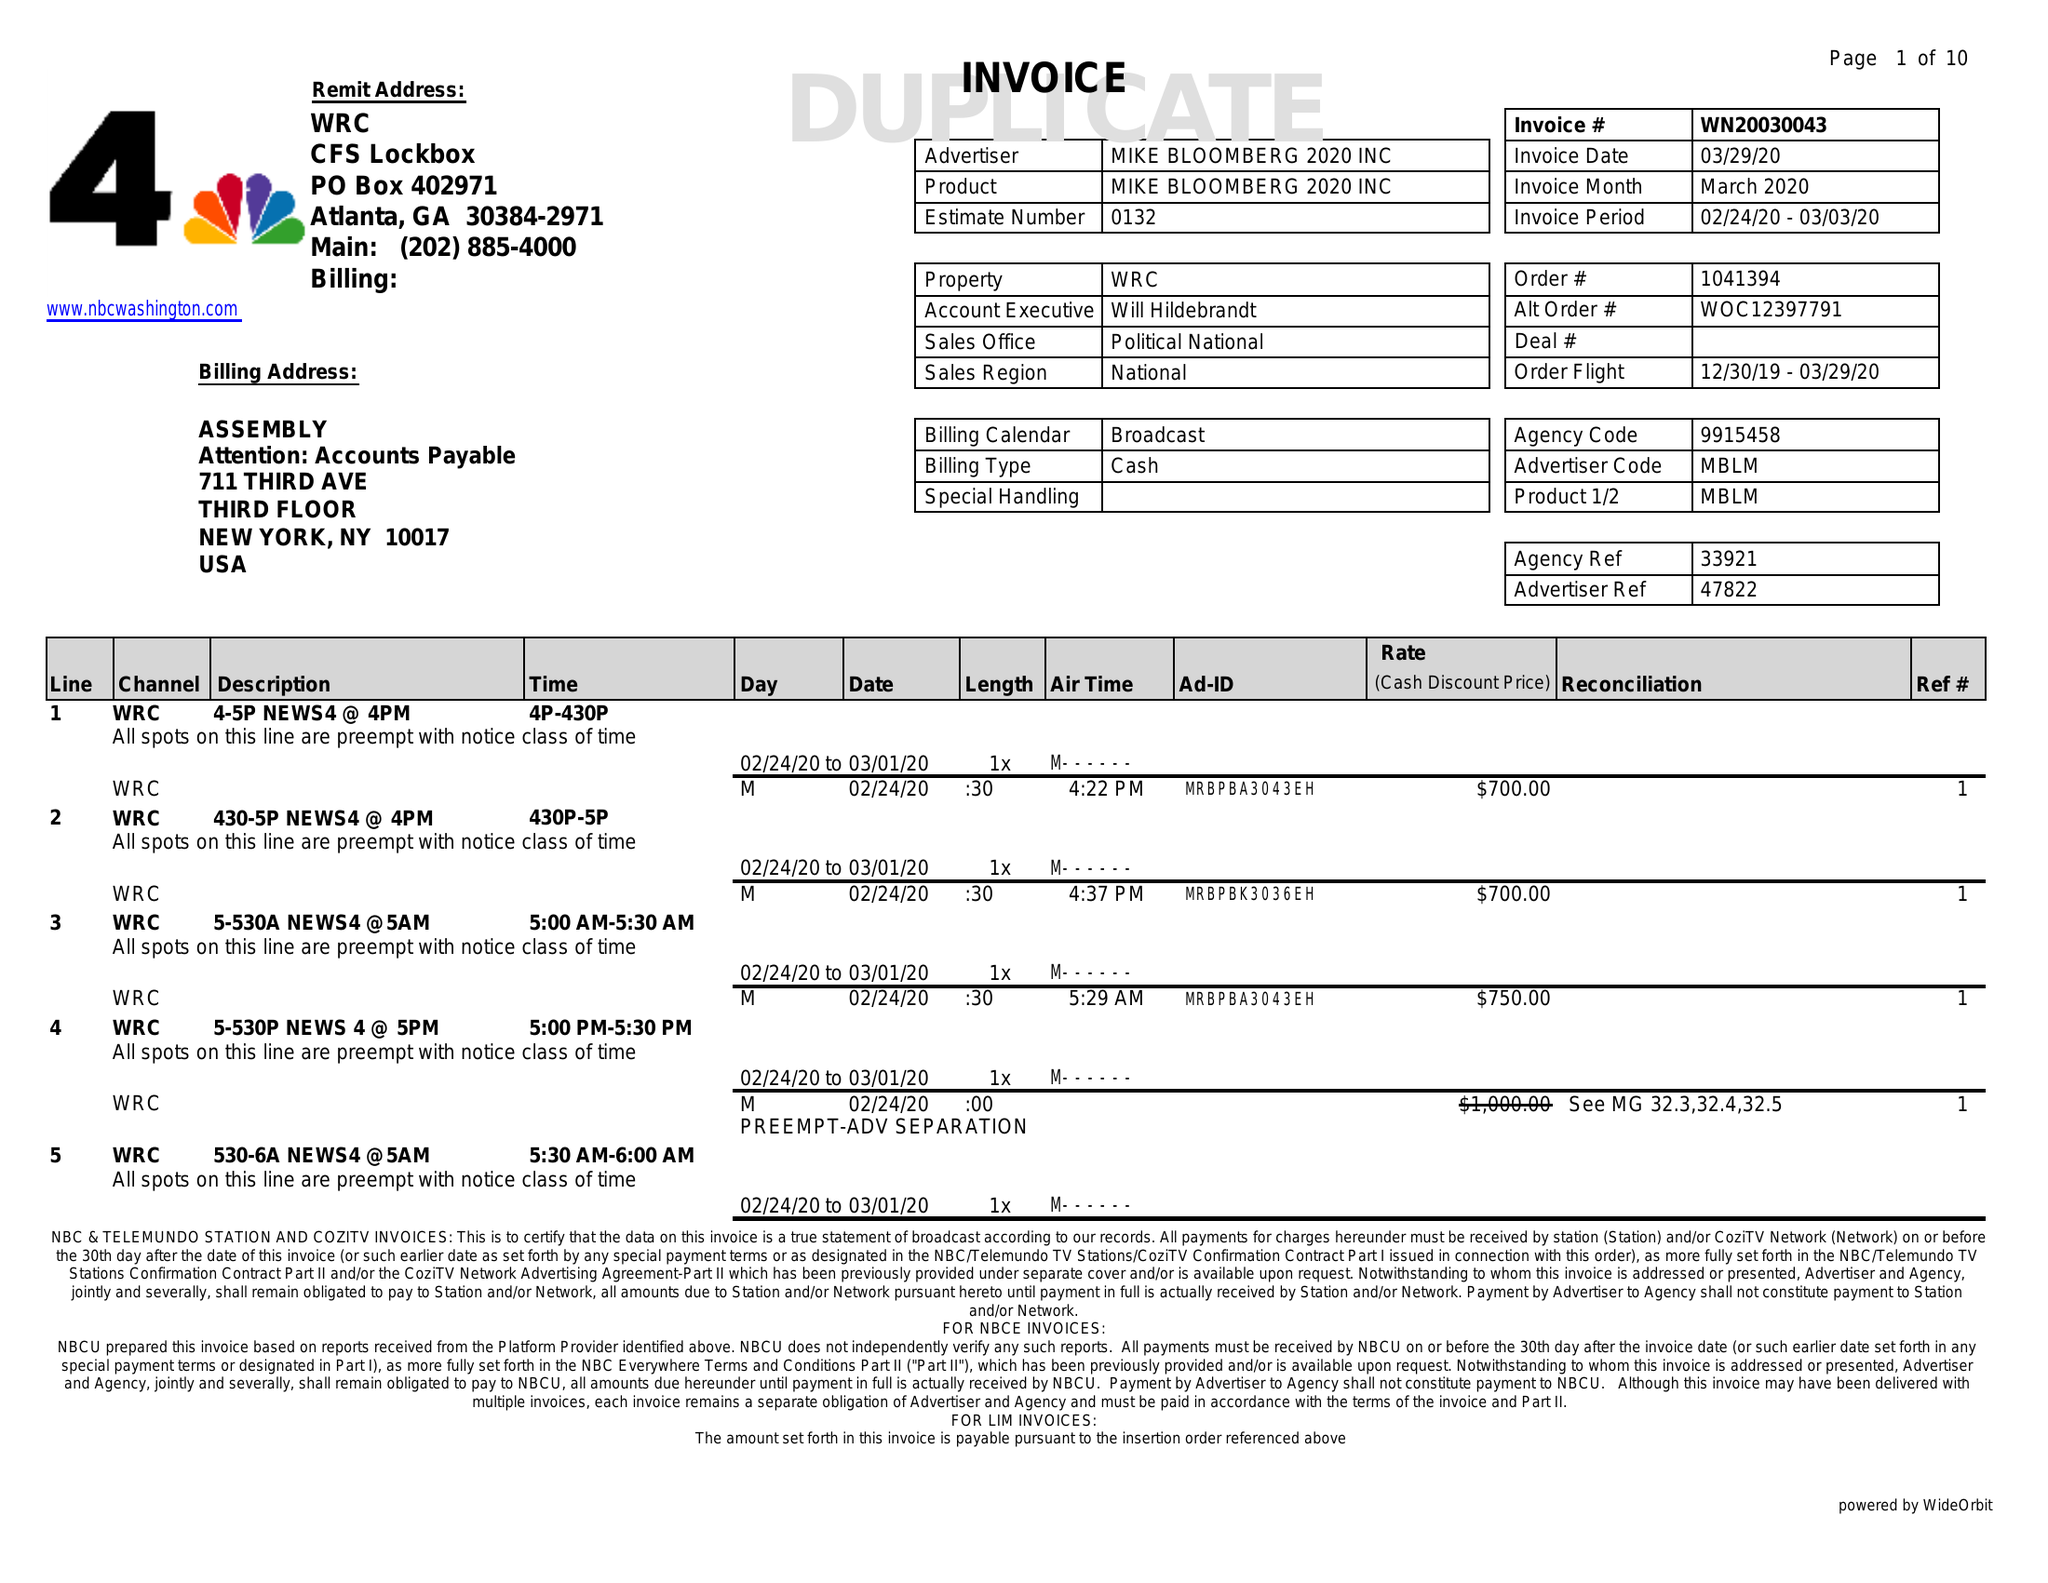What is the value for the contract_num?
Answer the question using a single word or phrase. WN20030043 